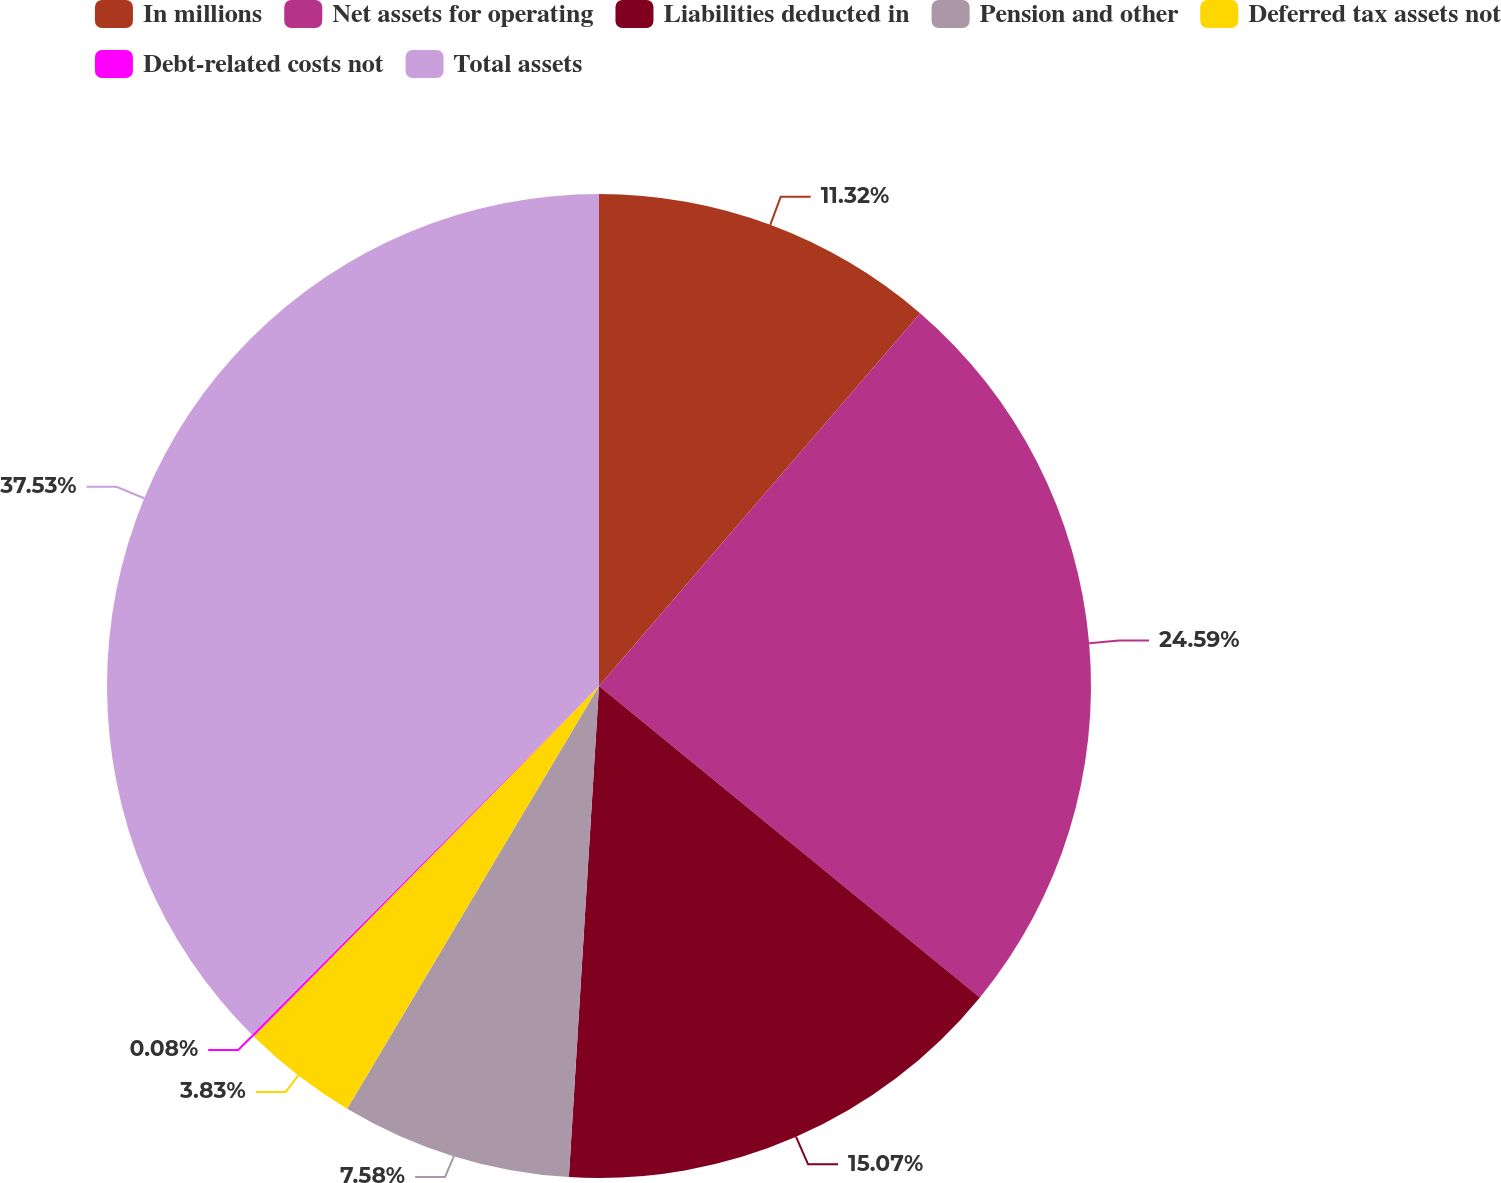Convert chart to OTSL. <chart><loc_0><loc_0><loc_500><loc_500><pie_chart><fcel>In millions<fcel>Net assets for operating<fcel>Liabilities deducted in<fcel>Pension and other<fcel>Deferred tax assets not<fcel>Debt-related costs not<fcel>Total assets<nl><fcel>11.32%<fcel>24.59%<fcel>15.07%<fcel>7.58%<fcel>3.83%<fcel>0.08%<fcel>37.54%<nl></chart> 